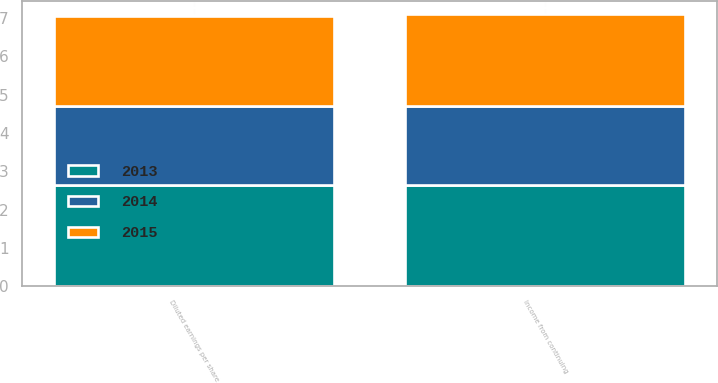<chart> <loc_0><loc_0><loc_500><loc_500><stacked_bar_chart><ecel><fcel>Income from continuing<fcel>Diluted earnings per share<nl><fcel>2013<fcel>2.64<fcel>2.64<nl><fcel>2015<fcel>2.39<fcel>2.35<nl><fcel>2014<fcel>2.07<fcel>2.06<nl></chart> 